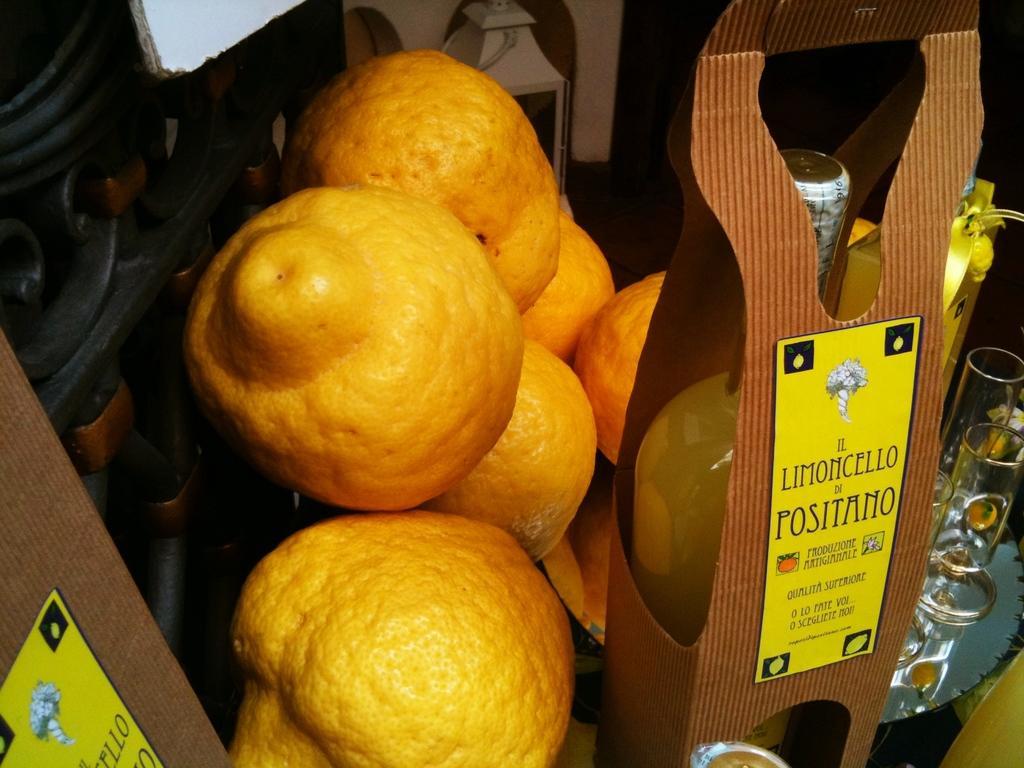Please provide a concise description of this image. In this image in the middle there are fruits and bottle kept in the box, on which there is a text, on the right side there is a text, on the left side there is a railing, at the top there is a lamp. 